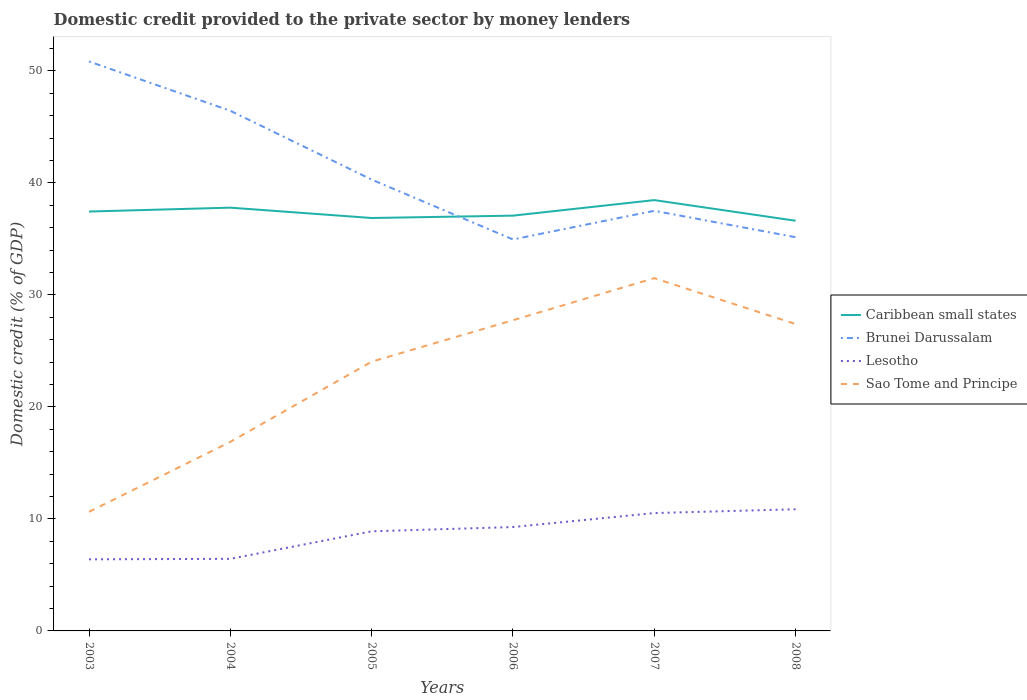Does the line corresponding to Brunei Darussalam intersect with the line corresponding to Sao Tome and Principe?
Keep it short and to the point. No. Across all years, what is the maximum domestic credit provided to the private sector by money lenders in Lesotho?
Provide a short and direct response. 6.39. In which year was the domestic credit provided to the private sector by money lenders in Caribbean small states maximum?
Provide a short and direct response. 2008. What is the total domestic credit provided to the private sector by money lenders in Lesotho in the graph?
Your answer should be very brief. -0.04. What is the difference between the highest and the second highest domestic credit provided to the private sector by money lenders in Caribbean small states?
Offer a very short reply. 1.84. Is the domestic credit provided to the private sector by money lenders in Lesotho strictly greater than the domestic credit provided to the private sector by money lenders in Brunei Darussalam over the years?
Give a very brief answer. Yes. How many years are there in the graph?
Offer a very short reply. 6. What is the difference between two consecutive major ticks on the Y-axis?
Offer a very short reply. 10. Are the values on the major ticks of Y-axis written in scientific E-notation?
Offer a terse response. No. Does the graph contain any zero values?
Provide a short and direct response. No. How many legend labels are there?
Provide a succinct answer. 4. What is the title of the graph?
Your response must be concise. Domestic credit provided to the private sector by money lenders. What is the label or title of the X-axis?
Give a very brief answer. Years. What is the label or title of the Y-axis?
Your answer should be very brief. Domestic credit (% of GDP). What is the Domestic credit (% of GDP) of Caribbean small states in 2003?
Provide a short and direct response. 37.44. What is the Domestic credit (% of GDP) in Brunei Darussalam in 2003?
Offer a terse response. 50.84. What is the Domestic credit (% of GDP) in Lesotho in 2003?
Offer a terse response. 6.39. What is the Domestic credit (% of GDP) in Sao Tome and Principe in 2003?
Provide a succinct answer. 10.64. What is the Domestic credit (% of GDP) in Caribbean small states in 2004?
Offer a very short reply. 37.79. What is the Domestic credit (% of GDP) of Brunei Darussalam in 2004?
Provide a short and direct response. 46.44. What is the Domestic credit (% of GDP) in Lesotho in 2004?
Ensure brevity in your answer.  6.44. What is the Domestic credit (% of GDP) of Sao Tome and Principe in 2004?
Your response must be concise. 16.88. What is the Domestic credit (% of GDP) of Caribbean small states in 2005?
Provide a short and direct response. 36.86. What is the Domestic credit (% of GDP) in Brunei Darussalam in 2005?
Make the answer very short. 40.29. What is the Domestic credit (% of GDP) in Lesotho in 2005?
Keep it short and to the point. 8.89. What is the Domestic credit (% of GDP) of Sao Tome and Principe in 2005?
Provide a short and direct response. 24.04. What is the Domestic credit (% of GDP) of Caribbean small states in 2006?
Give a very brief answer. 37.07. What is the Domestic credit (% of GDP) of Brunei Darussalam in 2006?
Keep it short and to the point. 34.95. What is the Domestic credit (% of GDP) in Lesotho in 2006?
Your answer should be compact. 9.27. What is the Domestic credit (% of GDP) of Sao Tome and Principe in 2006?
Your answer should be compact. 27.74. What is the Domestic credit (% of GDP) in Caribbean small states in 2007?
Ensure brevity in your answer.  38.46. What is the Domestic credit (% of GDP) in Brunei Darussalam in 2007?
Provide a succinct answer. 37.51. What is the Domestic credit (% of GDP) of Lesotho in 2007?
Keep it short and to the point. 10.52. What is the Domestic credit (% of GDP) of Sao Tome and Principe in 2007?
Your answer should be very brief. 31.49. What is the Domestic credit (% of GDP) in Caribbean small states in 2008?
Your answer should be very brief. 36.62. What is the Domestic credit (% of GDP) of Brunei Darussalam in 2008?
Provide a short and direct response. 35.15. What is the Domestic credit (% of GDP) in Lesotho in 2008?
Keep it short and to the point. 10.86. What is the Domestic credit (% of GDP) of Sao Tome and Principe in 2008?
Provide a short and direct response. 27.4. Across all years, what is the maximum Domestic credit (% of GDP) of Caribbean small states?
Provide a short and direct response. 38.46. Across all years, what is the maximum Domestic credit (% of GDP) of Brunei Darussalam?
Ensure brevity in your answer.  50.84. Across all years, what is the maximum Domestic credit (% of GDP) in Lesotho?
Provide a succinct answer. 10.86. Across all years, what is the maximum Domestic credit (% of GDP) of Sao Tome and Principe?
Provide a succinct answer. 31.49. Across all years, what is the minimum Domestic credit (% of GDP) of Caribbean small states?
Give a very brief answer. 36.62. Across all years, what is the minimum Domestic credit (% of GDP) in Brunei Darussalam?
Your response must be concise. 34.95. Across all years, what is the minimum Domestic credit (% of GDP) of Lesotho?
Offer a very short reply. 6.39. Across all years, what is the minimum Domestic credit (% of GDP) in Sao Tome and Principe?
Offer a terse response. 10.64. What is the total Domestic credit (% of GDP) of Caribbean small states in the graph?
Give a very brief answer. 224.25. What is the total Domestic credit (% of GDP) of Brunei Darussalam in the graph?
Give a very brief answer. 245.18. What is the total Domestic credit (% of GDP) of Lesotho in the graph?
Make the answer very short. 52.38. What is the total Domestic credit (% of GDP) in Sao Tome and Principe in the graph?
Your answer should be very brief. 138.18. What is the difference between the Domestic credit (% of GDP) of Caribbean small states in 2003 and that in 2004?
Provide a succinct answer. -0.35. What is the difference between the Domestic credit (% of GDP) in Brunei Darussalam in 2003 and that in 2004?
Your answer should be very brief. 4.4. What is the difference between the Domestic credit (% of GDP) in Lesotho in 2003 and that in 2004?
Give a very brief answer. -0.04. What is the difference between the Domestic credit (% of GDP) in Sao Tome and Principe in 2003 and that in 2004?
Your answer should be compact. -6.24. What is the difference between the Domestic credit (% of GDP) of Caribbean small states in 2003 and that in 2005?
Your response must be concise. 0.58. What is the difference between the Domestic credit (% of GDP) of Brunei Darussalam in 2003 and that in 2005?
Offer a very short reply. 10.55. What is the difference between the Domestic credit (% of GDP) in Lesotho in 2003 and that in 2005?
Keep it short and to the point. -2.5. What is the difference between the Domestic credit (% of GDP) in Sao Tome and Principe in 2003 and that in 2005?
Offer a very short reply. -13.4. What is the difference between the Domestic credit (% of GDP) of Caribbean small states in 2003 and that in 2006?
Your answer should be compact. 0.37. What is the difference between the Domestic credit (% of GDP) of Brunei Darussalam in 2003 and that in 2006?
Ensure brevity in your answer.  15.89. What is the difference between the Domestic credit (% of GDP) in Lesotho in 2003 and that in 2006?
Offer a terse response. -2.88. What is the difference between the Domestic credit (% of GDP) in Sao Tome and Principe in 2003 and that in 2006?
Your answer should be compact. -17.1. What is the difference between the Domestic credit (% of GDP) of Caribbean small states in 2003 and that in 2007?
Keep it short and to the point. -1.02. What is the difference between the Domestic credit (% of GDP) in Brunei Darussalam in 2003 and that in 2007?
Keep it short and to the point. 13.33. What is the difference between the Domestic credit (% of GDP) of Lesotho in 2003 and that in 2007?
Provide a succinct answer. -4.13. What is the difference between the Domestic credit (% of GDP) in Sao Tome and Principe in 2003 and that in 2007?
Your answer should be compact. -20.86. What is the difference between the Domestic credit (% of GDP) of Caribbean small states in 2003 and that in 2008?
Offer a terse response. 0.82. What is the difference between the Domestic credit (% of GDP) of Brunei Darussalam in 2003 and that in 2008?
Your answer should be compact. 15.69. What is the difference between the Domestic credit (% of GDP) of Lesotho in 2003 and that in 2008?
Offer a very short reply. -4.47. What is the difference between the Domestic credit (% of GDP) of Sao Tome and Principe in 2003 and that in 2008?
Offer a very short reply. -16.76. What is the difference between the Domestic credit (% of GDP) of Caribbean small states in 2004 and that in 2005?
Your answer should be very brief. 0.92. What is the difference between the Domestic credit (% of GDP) in Brunei Darussalam in 2004 and that in 2005?
Provide a succinct answer. 6.14. What is the difference between the Domestic credit (% of GDP) in Lesotho in 2004 and that in 2005?
Ensure brevity in your answer.  -2.46. What is the difference between the Domestic credit (% of GDP) of Sao Tome and Principe in 2004 and that in 2005?
Your answer should be very brief. -7.16. What is the difference between the Domestic credit (% of GDP) of Caribbean small states in 2004 and that in 2006?
Your response must be concise. 0.71. What is the difference between the Domestic credit (% of GDP) in Brunei Darussalam in 2004 and that in 2006?
Keep it short and to the point. 11.49. What is the difference between the Domestic credit (% of GDP) of Lesotho in 2004 and that in 2006?
Offer a very short reply. -2.84. What is the difference between the Domestic credit (% of GDP) in Sao Tome and Principe in 2004 and that in 2006?
Your response must be concise. -10.86. What is the difference between the Domestic credit (% of GDP) in Caribbean small states in 2004 and that in 2007?
Ensure brevity in your answer.  -0.67. What is the difference between the Domestic credit (% of GDP) in Brunei Darussalam in 2004 and that in 2007?
Make the answer very short. 8.93. What is the difference between the Domestic credit (% of GDP) of Lesotho in 2004 and that in 2007?
Your answer should be compact. -4.09. What is the difference between the Domestic credit (% of GDP) in Sao Tome and Principe in 2004 and that in 2007?
Keep it short and to the point. -14.61. What is the difference between the Domestic credit (% of GDP) in Caribbean small states in 2004 and that in 2008?
Offer a terse response. 1.17. What is the difference between the Domestic credit (% of GDP) of Brunei Darussalam in 2004 and that in 2008?
Your response must be concise. 11.28. What is the difference between the Domestic credit (% of GDP) of Lesotho in 2004 and that in 2008?
Give a very brief answer. -4.43. What is the difference between the Domestic credit (% of GDP) in Sao Tome and Principe in 2004 and that in 2008?
Ensure brevity in your answer.  -10.52. What is the difference between the Domestic credit (% of GDP) in Caribbean small states in 2005 and that in 2006?
Ensure brevity in your answer.  -0.21. What is the difference between the Domestic credit (% of GDP) of Brunei Darussalam in 2005 and that in 2006?
Your answer should be compact. 5.34. What is the difference between the Domestic credit (% of GDP) of Lesotho in 2005 and that in 2006?
Make the answer very short. -0.38. What is the difference between the Domestic credit (% of GDP) of Sao Tome and Principe in 2005 and that in 2006?
Give a very brief answer. -3.7. What is the difference between the Domestic credit (% of GDP) of Caribbean small states in 2005 and that in 2007?
Your answer should be very brief. -1.6. What is the difference between the Domestic credit (% of GDP) of Brunei Darussalam in 2005 and that in 2007?
Offer a very short reply. 2.78. What is the difference between the Domestic credit (% of GDP) in Lesotho in 2005 and that in 2007?
Give a very brief answer. -1.63. What is the difference between the Domestic credit (% of GDP) of Sao Tome and Principe in 2005 and that in 2007?
Your response must be concise. -7.46. What is the difference between the Domestic credit (% of GDP) in Caribbean small states in 2005 and that in 2008?
Ensure brevity in your answer.  0.24. What is the difference between the Domestic credit (% of GDP) of Brunei Darussalam in 2005 and that in 2008?
Provide a succinct answer. 5.14. What is the difference between the Domestic credit (% of GDP) in Lesotho in 2005 and that in 2008?
Your answer should be compact. -1.97. What is the difference between the Domestic credit (% of GDP) in Sao Tome and Principe in 2005 and that in 2008?
Offer a terse response. -3.36. What is the difference between the Domestic credit (% of GDP) of Caribbean small states in 2006 and that in 2007?
Offer a very short reply. -1.39. What is the difference between the Domestic credit (% of GDP) of Brunei Darussalam in 2006 and that in 2007?
Ensure brevity in your answer.  -2.56. What is the difference between the Domestic credit (% of GDP) in Lesotho in 2006 and that in 2007?
Your answer should be very brief. -1.25. What is the difference between the Domestic credit (% of GDP) of Sao Tome and Principe in 2006 and that in 2007?
Your answer should be very brief. -3.75. What is the difference between the Domestic credit (% of GDP) of Caribbean small states in 2006 and that in 2008?
Ensure brevity in your answer.  0.46. What is the difference between the Domestic credit (% of GDP) in Brunei Darussalam in 2006 and that in 2008?
Your answer should be compact. -0.2. What is the difference between the Domestic credit (% of GDP) in Lesotho in 2006 and that in 2008?
Give a very brief answer. -1.59. What is the difference between the Domestic credit (% of GDP) of Sao Tome and Principe in 2006 and that in 2008?
Give a very brief answer. 0.34. What is the difference between the Domestic credit (% of GDP) in Caribbean small states in 2007 and that in 2008?
Keep it short and to the point. 1.84. What is the difference between the Domestic credit (% of GDP) in Brunei Darussalam in 2007 and that in 2008?
Keep it short and to the point. 2.36. What is the difference between the Domestic credit (% of GDP) of Lesotho in 2007 and that in 2008?
Provide a succinct answer. -0.34. What is the difference between the Domestic credit (% of GDP) of Sao Tome and Principe in 2007 and that in 2008?
Provide a short and direct response. 4.1. What is the difference between the Domestic credit (% of GDP) of Caribbean small states in 2003 and the Domestic credit (% of GDP) of Brunei Darussalam in 2004?
Keep it short and to the point. -8.99. What is the difference between the Domestic credit (% of GDP) in Caribbean small states in 2003 and the Domestic credit (% of GDP) in Lesotho in 2004?
Make the answer very short. 31.01. What is the difference between the Domestic credit (% of GDP) in Caribbean small states in 2003 and the Domestic credit (% of GDP) in Sao Tome and Principe in 2004?
Offer a terse response. 20.56. What is the difference between the Domestic credit (% of GDP) in Brunei Darussalam in 2003 and the Domestic credit (% of GDP) in Lesotho in 2004?
Your response must be concise. 44.4. What is the difference between the Domestic credit (% of GDP) in Brunei Darussalam in 2003 and the Domestic credit (% of GDP) in Sao Tome and Principe in 2004?
Give a very brief answer. 33.96. What is the difference between the Domestic credit (% of GDP) in Lesotho in 2003 and the Domestic credit (% of GDP) in Sao Tome and Principe in 2004?
Provide a short and direct response. -10.49. What is the difference between the Domestic credit (% of GDP) in Caribbean small states in 2003 and the Domestic credit (% of GDP) in Brunei Darussalam in 2005?
Provide a short and direct response. -2.85. What is the difference between the Domestic credit (% of GDP) of Caribbean small states in 2003 and the Domestic credit (% of GDP) of Lesotho in 2005?
Make the answer very short. 28.55. What is the difference between the Domestic credit (% of GDP) in Caribbean small states in 2003 and the Domestic credit (% of GDP) in Sao Tome and Principe in 2005?
Your answer should be very brief. 13.41. What is the difference between the Domestic credit (% of GDP) of Brunei Darussalam in 2003 and the Domestic credit (% of GDP) of Lesotho in 2005?
Make the answer very short. 41.95. What is the difference between the Domestic credit (% of GDP) in Brunei Darussalam in 2003 and the Domestic credit (% of GDP) in Sao Tome and Principe in 2005?
Ensure brevity in your answer.  26.8. What is the difference between the Domestic credit (% of GDP) of Lesotho in 2003 and the Domestic credit (% of GDP) of Sao Tome and Principe in 2005?
Make the answer very short. -17.64. What is the difference between the Domestic credit (% of GDP) of Caribbean small states in 2003 and the Domestic credit (% of GDP) of Brunei Darussalam in 2006?
Your answer should be compact. 2.49. What is the difference between the Domestic credit (% of GDP) of Caribbean small states in 2003 and the Domestic credit (% of GDP) of Lesotho in 2006?
Provide a succinct answer. 28.17. What is the difference between the Domestic credit (% of GDP) of Caribbean small states in 2003 and the Domestic credit (% of GDP) of Sao Tome and Principe in 2006?
Provide a succinct answer. 9.7. What is the difference between the Domestic credit (% of GDP) in Brunei Darussalam in 2003 and the Domestic credit (% of GDP) in Lesotho in 2006?
Your answer should be very brief. 41.57. What is the difference between the Domestic credit (% of GDP) in Brunei Darussalam in 2003 and the Domestic credit (% of GDP) in Sao Tome and Principe in 2006?
Ensure brevity in your answer.  23.1. What is the difference between the Domestic credit (% of GDP) in Lesotho in 2003 and the Domestic credit (% of GDP) in Sao Tome and Principe in 2006?
Offer a very short reply. -21.35. What is the difference between the Domestic credit (% of GDP) in Caribbean small states in 2003 and the Domestic credit (% of GDP) in Brunei Darussalam in 2007?
Ensure brevity in your answer.  -0.07. What is the difference between the Domestic credit (% of GDP) of Caribbean small states in 2003 and the Domestic credit (% of GDP) of Lesotho in 2007?
Offer a very short reply. 26.92. What is the difference between the Domestic credit (% of GDP) of Caribbean small states in 2003 and the Domestic credit (% of GDP) of Sao Tome and Principe in 2007?
Give a very brief answer. 5.95. What is the difference between the Domestic credit (% of GDP) of Brunei Darussalam in 2003 and the Domestic credit (% of GDP) of Lesotho in 2007?
Provide a succinct answer. 40.32. What is the difference between the Domestic credit (% of GDP) of Brunei Darussalam in 2003 and the Domestic credit (% of GDP) of Sao Tome and Principe in 2007?
Ensure brevity in your answer.  19.35. What is the difference between the Domestic credit (% of GDP) in Lesotho in 2003 and the Domestic credit (% of GDP) in Sao Tome and Principe in 2007?
Keep it short and to the point. -25.1. What is the difference between the Domestic credit (% of GDP) in Caribbean small states in 2003 and the Domestic credit (% of GDP) in Brunei Darussalam in 2008?
Offer a terse response. 2.29. What is the difference between the Domestic credit (% of GDP) in Caribbean small states in 2003 and the Domestic credit (% of GDP) in Lesotho in 2008?
Your answer should be compact. 26.58. What is the difference between the Domestic credit (% of GDP) of Caribbean small states in 2003 and the Domestic credit (% of GDP) of Sao Tome and Principe in 2008?
Offer a very short reply. 10.05. What is the difference between the Domestic credit (% of GDP) in Brunei Darussalam in 2003 and the Domestic credit (% of GDP) in Lesotho in 2008?
Provide a short and direct response. 39.98. What is the difference between the Domestic credit (% of GDP) of Brunei Darussalam in 2003 and the Domestic credit (% of GDP) of Sao Tome and Principe in 2008?
Keep it short and to the point. 23.44. What is the difference between the Domestic credit (% of GDP) in Lesotho in 2003 and the Domestic credit (% of GDP) in Sao Tome and Principe in 2008?
Keep it short and to the point. -21.01. What is the difference between the Domestic credit (% of GDP) in Caribbean small states in 2004 and the Domestic credit (% of GDP) in Brunei Darussalam in 2005?
Your answer should be compact. -2.5. What is the difference between the Domestic credit (% of GDP) in Caribbean small states in 2004 and the Domestic credit (% of GDP) in Lesotho in 2005?
Ensure brevity in your answer.  28.9. What is the difference between the Domestic credit (% of GDP) of Caribbean small states in 2004 and the Domestic credit (% of GDP) of Sao Tome and Principe in 2005?
Make the answer very short. 13.75. What is the difference between the Domestic credit (% of GDP) of Brunei Darussalam in 2004 and the Domestic credit (% of GDP) of Lesotho in 2005?
Your answer should be compact. 37.54. What is the difference between the Domestic credit (% of GDP) in Brunei Darussalam in 2004 and the Domestic credit (% of GDP) in Sao Tome and Principe in 2005?
Provide a short and direct response. 22.4. What is the difference between the Domestic credit (% of GDP) of Lesotho in 2004 and the Domestic credit (% of GDP) of Sao Tome and Principe in 2005?
Offer a terse response. -17.6. What is the difference between the Domestic credit (% of GDP) in Caribbean small states in 2004 and the Domestic credit (% of GDP) in Brunei Darussalam in 2006?
Your response must be concise. 2.84. What is the difference between the Domestic credit (% of GDP) of Caribbean small states in 2004 and the Domestic credit (% of GDP) of Lesotho in 2006?
Offer a very short reply. 28.51. What is the difference between the Domestic credit (% of GDP) of Caribbean small states in 2004 and the Domestic credit (% of GDP) of Sao Tome and Principe in 2006?
Offer a terse response. 10.05. What is the difference between the Domestic credit (% of GDP) of Brunei Darussalam in 2004 and the Domestic credit (% of GDP) of Lesotho in 2006?
Give a very brief answer. 37.16. What is the difference between the Domestic credit (% of GDP) in Brunei Darussalam in 2004 and the Domestic credit (% of GDP) in Sao Tome and Principe in 2006?
Make the answer very short. 18.7. What is the difference between the Domestic credit (% of GDP) of Lesotho in 2004 and the Domestic credit (% of GDP) of Sao Tome and Principe in 2006?
Your answer should be very brief. -21.3. What is the difference between the Domestic credit (% of GDP) in Caribbean small states in 2004 and the Domestic credit (% of GDP) in Brunei Darussalam in 2007?
Your answer should be very brief. 0.28. What is the difference between the Domestic credit (% of GDP) in Caribbean small states in 2004 and the Domestic credit (% of GDP) in Lesotho in 2007?
Your response must be concise. 27.27. What is the difference between the Domestic credit (% of GDP) in Caribbean small states in 2004 and the Domestic credit (% of GDP) in Sao Tome and Principe in 2007?
Offer a terse response. 6.29. What is the difference between the Domestic credit (% of GDP) in Brunei Darussalam in 2004 and the Domestic credit (% of GDP) in Lesotho in 2007?
Give a very brief answer. 35.91. What is the difference between the Domestic credit (% of GDP) in Brunei Darussalam in 2004 and the Domestic credit (% of GDP) in Sao Tome and Principe in 2007?
Keep it short and to the point. 14.94. What is the difference between the Domestic credit (% of GDP) in Lesotho in 2004 and the Domestic credit (% of GDP) in Sao Tome and Principe in 2007?
Offer a terse response. -25.06. What is the difference between the Domestic credit (% of GDP) in Caribbean small states in 2004 and the Domestic credit (% of GDP) in Brunei Darussalam in 2008?
Offer a terse response. 2.64. What is the difference between the Domestic credit (% of GDP) in Caribbean small states in 2004 and the Domestic credit (% of GDP) in Lesotho in 2008?
Provide a short and direct response. 26.93. What is the difference between the Domestic credit (% of GDP) of Caribbean small states in 2004 and the Domestic credit (% of GDP) of Sao Tome and Principe in 2008?
Your response must be concise. 10.39. What is the difference between the Domestic credit (% of GDP) of Brunei Darussalam in 2004 and the Domestic credit (% of GDP) of Lesotho in 2008?
Offer a very short reply. 35.57. What is the difference between the Domestic credit (% of GDP) in Brunei Darussalam in 2004 and the Domestic credit (% of GDP) in Sao Tome and Principe in 2008?
Make the answer very short. 19.04. What is the difference between the Domestic credit (% of GDP) of Lesotho in 2004 and the Domestic credit (% of GDP) of Sao Tome and Principe in 2008?
Ensure brevity in your answer.  -20.96. What is the difference between the Domestic credit (% of GDP) in Caribbean small states in 2005 and the Domestic credit (% of GDP) in Brunei Darussalam in 2006?
Your answer should be very brief. 1.91. What is the difference between the Domestic credit (% of GDP) of Caribbean small states in 2005 and the Domestic credit (% of GDP) of Lesotho in 2006?
Ensure brevity in your answer.  27.59. What is the difference between the Domestic credit (% of GDP) in Caribbean small states in 2005 and the Domestic credit (% of GDP) in Sao Tome and Principe in 2006?
Provide a short and direct response. 9.12. What is the difference between the Domestic credit (% of GDP) of Brunei Darussalam in 2005 and the Domestic credit (% of GDP) of Lesotho in 2006?
Your response must be concise. 31.02. What is the difference between the Domestic credit (% of GDP) in Brunei Darussalam in 2005 and the Domestic credit (% of GDP) in Sao Tome and Principe in 2006?
Provide a succinct answer. 12.55. What is the difference between the Domestic credit (% of GDP) of Lesotho in 2005 and the Domestic credit (% of GDP) of Sao Tome and Principe in 2006?
Offer a very short reply. -18.85. What is the difference between the Domestic credit (% of GDP) of Caribbean small states in 2005 and the Domestic credit (% of GDP) of Brunei Darussalam in 2007?
Ensure brevity in your answer.  -0.64. What is the difference between the Domestic credit (% of GDP) in Caribbean small states in 2005 and the Domestic credit (% of GDP) in Lesotho in 2007?
Offer a terse response. 26.34. What is the difference between the Domestic credit (% of GDP) in Caribbean small states in 2005 and the Domestic credit (% of GDP) in Sao Tome and Principe in 2007?
Make the answer very short. 5.37. What is the difference between the Domestic credit (% of GDP) in Brunei Darussalam in 2005 and the Domestic credit (% of GDP) in Lesotho in 2007?
Ensure brevity in your answer.  29.77. What is the difference between the Domestic credit (% of GDP) of Brunei Darussalam in 2005 and the Domestic credit (% of GDP) of Sao Tome and Principe in 2007?
Offer a very short reply. 8.8. What is the difference between the Domestic credit (% of GDP) of Lesotho in 2005 and the Domestic credit (% of GDP) of Sao Tome and Principe in 2007?
Give a very brief answer. -22.6. What is the difference between the Domestic credit (% of GDP) in Caribbean small states in 2005 and the Domestic credit (% of GDP) in Brunei Darussalam in 2008?
Offer a terse response. 1.71. What is the difference between the Domestic credit (% of GDP) of Caribbean small states in 2005 and the Domestic credit (% of GDP) of Lesotho in 2008?
Provide a succinct answer. 26. What is the difference between the Domestic credit (% of GDP) of Caribbean small states in 2005 and the Domestic credit (% of GDP) of Sao Tome and Principe in 2008?
Offer a terse response. 9.47. What is the difference between the Domestic credit (% of GDP) of Brunei Darussalam in 2005 and the Domestic credit (% of GDP) of Lesotho in 2008?
Offer a terse response. 29.43. What is the difference between the Domestic credit (% of GDP) in Brunei Darussalam in 2005 and the Domestic credit (% of GDP) in Sao Tome and Principe in 2008?
Your answer should be compact. 12.9. What is the difference between the Domestic credit (% of GDP) of Lesotho in 2005 and the Domestic credit (% of GDP) of Sao Tome and Principe in 2008?
Your answer should be compact. -18.5. What is the difference between the Domestic credit (% of GDP) of Caribbean small states in 2006 and the Domestic credit (% of GDP) of Brunei Darussalam in 2007?
Give a very brief answer. -0.43. What is the difference between the Domestic credit (% of GDP) of Caribbean small states in 2006 and the Domestic credit (% of GDP) of Lesotho in 2007?
Your answer should be very brief. 26.55. What is the difference between the Domestic credit (% of GDP) in Caribbean small states in 2006 and the Domestic credit (% of GDP) in Sao Tome and Principe in 2007?
Your answer should be very brief. 5.58. What is the difference between the Domestic credit (% of GDP) of Brunei Darussalam in 2006 and the Domestic credit (% of GDP) of Lesotho in 2007?
Make the answer very short. 24.43. What is the difference between the Domestic credit (% of GDP) in Brunei Darussalam in 2006 and the Domestic credit (% of GDP) in Sao Tome and Principe in 2007?
Your answer should be very brief. 3.46. What is the difference between the Domestic credit (% of GDP) in Lesotho in 2006 and the Domestic credit (% of GDP) in Sao Tome and Principe in 2007?
Provide a short and direct response. -22.22. What is the difference between the Domestic credit (% of GDP) in Caribbean small states in 2006 and the Domestic credit (% of GDP) in Brunei Darussalam in 2008?
Offer a terse response. 1.92. What is the difference between the Domestic credit (% of GDP) of Caribbean small states in 2006 and the Domestic credit (% of GDP) of Lesotho in 2008?
Offer a terse response. 26.21. What is the difference between the Domestic credit (% of GDP) of Caribbean small states in 2006 and the Domestic credit (% of GDP) of Sao Tome and Principe in 2008?
Offer a terse response. 9.68. What is the difference between the Domestic credit (% of GDP) of Brunei Darussalam in 2006 and the Domestic credit (% of GDP) of Lesotho in 2008?
Offer a very short reply. 24.09. What is the difference between the Domestic credit (% of GDP) in Brunei Darussalam in 2006 and the Domestic credit (% of GDP) in Sao Tome and Principe in 2008?
Provide a succinct answer. 7.55. What is the difference between the Domestic credit (% of GDP) of Lesotho in 2006 and the Domestic credit (% of GDP) of Sao Tome and Principe in 2008?
Ensure brevity in your answer.  -18.12. What is the difference between the Domestic credit (% of GDP) in Caribbean small states in 2007 and the Domestic credit (% of GDP) in Brunei Darussalam in 2008?
Provide a short and direct response. 3.31. What is the difference between the Domestic credit (% of GDP) of Caribbean small states in 2007 and the Domestic credit (% of GDP) of Lesotho in 2008?
Ensure brevity in your answer.  27.6. What is the difference between the Domestic credit (% of GDP) in Caribbean small states in 2007 and the Domestic credit (% of GDP) in Sao Tome and Principe in 2008?
Your response must be concise. 11.07. What is the difference between the Domestic credit (% of GDP) of Brunei Darussalam in 2007 and the Domestic credit (% of GDP) of Lesotho in 2008?
Your response must be concise. 26.65. What is the difference between the Domestic credit (% of GDP) of Brunei Darussalam in 2007 and the Domestic credit (% of GDP) of Sao Tome and Principe in 2008?
Your answer should be very brief. 10.11. What is the difference between the Domestic credit (% of GDP) of Lesotho in 2007 and the Domestic credit (% of GDP) of Sao Tome and Principe in 2008?
Your answer should be very brief. -16.87. What is the average Domestic credit (% of GDP) in Caribbean small states per year?
Provide a short and direct response. 37.38. What is the average Domestic credit (% of GDP) of Brunei Darussalam per year?
Provide a succinct answer. 40.86. What is the average Domestic credit (% of GDP) of Lesotho per year?
Give a very brief answer. 8.73. What is the average Domestic credit (% of GDP) in Sao Tome and Principe per year?
Keep it short and to the point. 23.03. In the year 2003, what is the difference between the Domestic credit (% of GDP) of Caribbean small states and Domestic credit (% of GDP) of Brunei Darussalam?
Keep it short and to the point. -13.4. In the year 2003, what is the difference between the Domestic credit (% of GDP) of Caribbean small states and Domestic credit (% of GDP) of Lesotho?
Provide a short and direct response. 31.05. In the year 2003, what is the difference between the Domestic credit (% of GDP) in Caribbean small states and Domestic credit (% of GDP) in Sao Tome and Principe?
Provide a short and direct response. 26.81. In the year 2003, what is the difference between the Domestic credit (% of GDP) in Brunei Darussalam and Domestic credit (% of GDP) in Lesotho?
Your answer should be very brief. 44.45. In the year 2003, what is the difference between the Domestic credit (% of GDP) of Brunei Darussalam and Domestic credit (% of GDP) of Sao Tome and Principe?
Ensure brevity in your answer.  40.2. In the year 2003, what is the difference between the Domestic credit (% of GDP) in Lesotho and Domestic credit (% of GDP) in Sao Tome and Principe?
Your response must be concise. -4.24. In the year 2004, what is the difference between the Domestic credit (% of GDP) of Caribbean small states and Domestic credit (% of GDP) of Brunei Darussalam?
Your response must be concise. -8.65. In the year 2004, what is the difference between the Domestic credit (% of GDP) of Caribbean small states and Domestic credit (% of GDP) of Lesotho?
Provide a short and direct response. 31.35. In the year 2004, what is the difference between the Domestic credit (% of GDP) in Caribbean small states and Domestic credit (% of GDP) in Sao Tome and Principe?
Make the answer very short. 20.91. In the year 2004, what is the difference between the Domestic credit (% of GDP) of Brunei Darussalam and Domestic credit (% of GDP) of Lesotho?
Provide a succinct answer. 40. In the year 2004, what is the difference between the Domestic credit (% of GDP) of Brunei Darussalam and Domestic credit (% of GDP) of Sao Tome and Principe?
Your response must be concise. 29.56. In the year 2004, what is the difference between the Domestic credit (% of GDP) of Lesotho and Domestic credit (% of GDP) of Sao Tome and Principe?
Ensure brevity in your answer.  -10.44. In the year 2005, what is the difference between the Domestic credit (% of GDP) in Caribbean small states and Domestic credit (% of GDP) in Brunei Darussalam?
Provide a succinct answer. -3.43. In the year 2005, what is the difference between the Domestic credit (% of GDP) in Caribbean small states and Domestic credit (% of GDP) in Lesotho?
Keep it short and to the point. 27.97. In the year 2005, what is the difference between the Domestic credit (% of GDP) in Caribbean small states and Domestic credit (% of GDP) in Sao Tome and Principe?
Offer a terse response. 12.83. In the year 2005, what is the difference between the Domestic credit (% of GDP) of Brunei Darussalam and Domestic credit (% of GDP) of Lesotho?
Keep it short and to the point. 31.4. In the year 2005, what is the difference between the Domestic credit (% of GDP) of Brunei Darussalam and Domestic credit (% of GDP) of Sao Tome and Principe?
Provide a succinct answer. 16.26. In the year 2005, what is the difference between the Domestic credit (% of GDP) in Lesotho and Domestic credit (% of GDP) in Sao Tome and Principe?
Give a very brief answer. -15.14. In the year 2006, what is the difference between the Domestic credit (% of GDP) in Caribbean small states and Domestic credit (% of GDP) in Brunei Darussalam?
Your response must be concise. 2.12. In the year 2006, what is the difference between the Domestic credit (% of GDP) in Caribbean small states and Domestic credit (% of GDP) in Lesotho?
Provide a succinct answer. 27.8. In the year 2006, what is the difference between the Domestic credit (% of GDP) of Caribbean small states and Domestic credit (% of GDP) of Sao Tome and Principe?
Keep it short and to the point. 9.34. In the year 2006, what is the difference between the Domestic credit (% of GDP) in Brunei Darussalam and Domestic credit (% of GDP) in Lesotho?
Your answer should be very brief. 25.68. In the year 2006, what is the difference between the Domestic credit (% of GDP) in Brunei Darussalam and Domestic credit (% of GDP) in Sao Tome and Principe?
Provide a succinct answer. 7.21. In the year 2006, what is the difference between the Domestic credit (% of GDP) in Lesotho and Domestic credit (% of GDP) in Sao Tome and Principe?
Your answer should be compact. -18.47. In the year 2007, what is the difference between the Domestic credit (% of GDP) of Caribbean small states and Domestic credit (% of GDP) of Brunei Darussalam?
Offer a very short reply. 0.95. In the year 2007, what is the difference between the Domestic credit (% of GDP) in Caribbean small states and Domestic credit (% of GDP) in Lesotho?
Offer a terse response. 27.94. In the year 2007, what is the difference between the Domestic credit (% of GDP) in Caribbean small states and Domestic credit (% of GDP) in Sao Tome and Principe?
Give a very brief answer. 6.97. In the year 2007, what is the difference between the Domestic credit (% of GDP) in Brunei Darussalam and Domestic credit (% of GDP) in Lesotho?
Give a very brief answer. 26.99. In the year 2007, what is the difference between the Domestic credit (% of GDP) of Brunei Darussalam and Domestic credit (% of GDP) of Sao Tome and Principe?
Provide a short and direct response. 6.01. In the year 2007, what is the difference between the Domestic credit (% of GDP) of Lesotho and Domestic credit (% of GDP) of Sao Tome and Principe?
Ensure brevity in your answer.  -20.97. In the year 2008, what is the difference between the Domestic credit (% of GDP) of Caribbean small states and Domestic credit (% of GDP) of Brunei Darussalam?
Your answer should be very brief. 1.47. In the year 2008, what is the difference between the Domestic credit (% of GDP) of Caribbean small states and Domestic credit (% of GDP) of Lesotho?
Your response must be concise. 25.76. In the year 2008, what is the difference between the Domestic credit (% of GDP) in Caribbean small states and Domestic credit (% of GDP) in Sao Tome and Principe?
Your response must be concise. 9.22. In the year 2008, what is the difference between the Domestic credit (% of GDP) of Brunei Darussalam and Domestic credit (% of GDP) of Lesotho?
Provide a short and direct response. 24.29. In the year 2008, what is the difference between the Domestic credit (% of GDP) of Brunei Darussalam and Domestic credit (% of GDP) of Sao Tome and Principe?
Your answer should be compact. 7.76. In the year 2008, what is the difference between the Domestic credit (% of GDP) in Lesotho and Domestic credit (% of GDP) in Sao Tome and Principe?
Offer a terse response. -16.54. What is the ratio of the Domestic credit (% of GDP) of Caribbean small states in 2003 to that in 2004?
Offer a terse response. 0.99. What is the ratio of the Domestic credit (% of GDP) in Brunei Darussalam in 2003 to that in 2004?
Keep it short and to the point. 1.09. What is the ratio of the Domestic credit (% of GDP) of Lesotho in 2003 to that in 2004?
Ensure brevity in your answer.  0.99. What is the ratio of the Domestic credit (% of GDP) in Sao Tome and Principe in 2003 to that in 2004?
Make the answer very short. 0.63. What is the ratio of the Domestic credit (% of GDP) of Caribbean small states in 2003 to that in 2005?
Provide a short and direct response. 1.02. What is the ratio of the Domestic credit (% of GDP) of Brunei Darussalam in 2003 to that in 2005?
Offer a very short reply. 1.26. What is the ratio of the Domestic credit (% of GDP) of Lesotho in 2003 to that in 2005?
Your answer should be very brief. 0.72. What is the ratio of the Domestic credit (% of GDP) of Sao Tome and Principe in 2003 to that in 2005?
Your answer should be compact. 0.44. What is the ratio of the Domestic credit (% of GDP) of Caribbean small states in 2003 to that in 2006?
Provide a succinct answer. 1.01. What is the ratio of the Domestic credit (% of GDP) of Brunei Darussalam in 2003 to that in 2006?
Provide a short and direct response. 1.45. What is the ratio of the Domestic credit (% of GDP) of Lesotho in 2003 to that in 2006?
Offer a terse response. 0.69. What is the ratio of the Domestic credit (% of GDP) of Sao Tome and Principe in 2003 to that in 2006?
Give a very brief answer. 0.38. What is the ratio of the Domestic credit (% of GDP) in Caribbean small states in 2003 to that in 2007?
Your answer should be very brief. 0.97. What is the ratio of the Domestic credit (% of GDP) of Brunei Darussalam in 2003 to that in 2007?
Your answer should be very brief. 1.36. What is the ratio of the Domestic credit (% of GDP) of Lesotho in 2003 to that in 2007?
Provide a short and direct response. 0.61. What is the ratio of the Domestic credit (% of GDP) in Sao Tome and Principe in 2003 to that in 2007?
Offer a terse response. 0.34. What is the ratio of the Domestic credit (% of GDP) of Caribbean small states in 2003 to that in 2008?
Keep it short and to the point. 1.02. What is the ratio of the Domestic credit (% of GDP) of Brunei Darussalam in 2003 to that in 2008?
Your answer should be very brief. 1.45. What is the ratio of the Domestic credit (% of GDP) in Lesotho in 2003 to that in 2008?
Ensure brevity in your answer.  0.59. What is the ratio of the Domestic credit (% of GDP) in Sao Tome and Principe in 2003 to that in 2008?
Provide a succinct answer. 0.39. What is the ratio of the Domestic credit (% of GDP) in Caribbean small states in 2004 to that in 2005?
Ensure brevity in your answer.  1.03. What is the ratio of the Domestic credit (% of GDP) in Brunei Darussalam in 2004 to that in 2005?
Keep it short and to the point. 1.15. What is the ratio of the Domestic credit (% of GDP) of Lesotho in 2004 to that in 2005?
Keep it short and to the point. 0.72. What is the ratio of the Domestic credit (% of GDP) of Sao Tome and Principe in 2004 to that in 2005?
Your answer should be compact. 0.7. What is the ratio of the Domestic credit (% of GDP) of Caribbean small states in 2004 to that in 2006?
Offer a terse response. 1.02. What is the ratio of the Domestic credit (% of GDP) in Brunei Darussalam in 2004 to that in 2006?
Your response must be concise. 1.33. What is the ratio of the Domestic credit (% of GDP) of Lesotho in 2004 to that in 2006?
Ensure brevity in your answer.  0.69. What is the ratio of the Domestic credit (% of GDP) in Sao Tome and Principe in 2004 to that in 2006?
Give a very brief answer. 0.61. What is the ratio of the Domestic credit (% of GDP) of Caribbean small states in 2004 to that in 2007?
Your answer should be very brief. 0.98. What is the ratio of the Domestic credit (% of GDP) in Brunei Darussalam in 2004 to that in 2007?
Provide a short and direct response. 1.24. What is the ratio of the Domestic credit (% of GDP) in Lesotho in 2004 to that in 2007?
Keep it short and to the point. 0.61. What is the ratio of the Domestic credit (% of GDP) of Sao Tome and Principe in 2004 to that in 2007?
Offer a terse response. 0.54. What is the ratio of the Domestic credit (% of GDP) in Caribbean small states in 2004 to that in 2008?
Provide a succinct answer. 1.03. What is the ratio of the Domestic credit (% of GDP) of Brunei Darussalam in 2004 to that in 2008?
Your answer should be very brief. 1.32. What is the ratio of the Domestic credit (% of GDP) in Lesotho in 2004 to that in 2008?
Your response must be concise. 0.59. What is the ratio of the Domestic credit (% of GDP) of Sao Tome and Principe in 2004 to that in 2008?
Keep it short and to the point. 0.62. What is the ratio of the Domestic credit (% of GDP) of Caribbean small states in 2005 to that in 2006?
Offer a very short reply. 0.99. What is the ratio of the Domestic credit (% of GDP) in Brunei Darussalam in 2005 to that in 2006?
Your response must be concise. 1.15. What is the ratio of the Domestic credit (% of GDP) in Lesotho in 2005 to that in 2006?
Keep it short and to the point. 0.96. What is the ratio of the Domestic credit (% of GDP) in Sao Tome and Principe in 2005 to that in 2006?
Your answer should be very brief. 0.87. What is the ratio of the Domestic credit (% of GDP) of Caribbean small states in 2005 to that in 2007?
Your answer should be compact. 0.96. What is the ratio of the Domestic credit (% of GDP) of Brunei Darussalam in 2005 to that in 2007?
Your answer should be very brief. 1.07. What is the ratio of the Domestic credit (% of GDP) of Lesotho in 2005 to that in 2007?
Offer a terse response. 0.85. What is the ratio of the Domestic credit (% of GDP) in Sao Tome and Principe in 2005 to that in 2007?
Make the answer very short. 0.76. What is the ratio of the Domestic credit (% of GDP) in Brunei Darussalam in 2005 to that in 2008?
Provide a succinct answer. 1.15. What is the ratio of the Domestic credit (% of GDP) in Lesotho in 2005 to that in 2008?
Your answer should be compact. 0.82. What is the ratio of the Domestic credit (% of GDP) of Sao Tome and Principe in 2005 to that in 2008?
Offer a very short reply. 0.88. What is the ratio of the Domestic credit (% of GDP) of Caribbean small states in 2006 to that in 2007?
Your answer should be compact. 0.96. What is the ratio of the Domestic credit (% of GDP) in Brunei Darussalam in 2006 to that in 2007?
Ensure brevity in your answer.  0.93. What is the ratio of the Domestic credit (% of GDP) in Lesotho in 2006 to that in 2007?
Offer a very short reply. 0.88. What is the ratio of the Domestic credit (% of GDP) of Sao Tome and Principe in 2006 to that in 2007?
Offer a terse response. 0.88. What is the ratio of the Domestic credit (% of GDP) of Caribbean small states in 2006 to that in 2008?
Your answer should be compact. 1.01. What is the ratio of the Domestic credit (% of GDP) of Brunei Darussalam in 2006 to that in 2008?
Offer a very short reply. 0.99. What is the ratio of the Domestic credit (% of GDP) of Lesotho in 2006 to that in 2008?
Offer a terse response. 0.85. What is the ratio of the Domestic credit (% of GDP) in Sao Tome and Principe in 2006 to that in 2008?
Ensure brevity in your answer.  1.01. What is the ratio of the Domestic credit (% of GDP) in Caribbean small states in 2007 to that in 2008?
Keep it short and to the point. 1.05. What is the ratio of the Domestic credit (% of GDP) of Brunei Darussalam in 2007 to that in 2008?
Make the answer very short. 1.07. What is the ratio of the Domestic credit (% of GDP) in Lesotho in 2007 to that in 2008?
Your answer should be compact. 0.97. What is the ratio of the Domestic credit (% of GDP) in Sao Tome and Principe in 2007 to that in 2008?
Offer a very short reply. 1.15. What is the difference between the highest and the second highest Domestic credit (% of GDP) of Caribbean small states?
Keep it short and to the point. 0.67. What is the difference between the highest and the second highest Domestic credit (% of GDP) of Brunei Darussalam?
Ensure brevity in your answer.  4.4. What is the difference between the highest and the second highest Domestic credit (% of GDP) of Lesotho?
Provide a short and direct response. 0.34. What is the difference between the highest and the second highest Domestic credit (% of GDP) in Sao Tome and Principe?
Offer a terse response. 3.75. What is the difference between the highest and the lowest Domestic credit (% of GDP) in Caribbean small states?
Your answer should be compact. 1.84. What is the difference between the highest and the lowest Domestic credit (% of GDP) of Brunei Darussalam?
Offer a very short reply. 15.89. What is the difference between the highest and the lowest Domestic credit (% of GDP) in Lesotho?
Offer a terse response. 4.47. What is the difference between the highest and the lowest Domestic credit (% of GDP) in Sao Tome and Principe?
Make the answer very short. 20.86. 